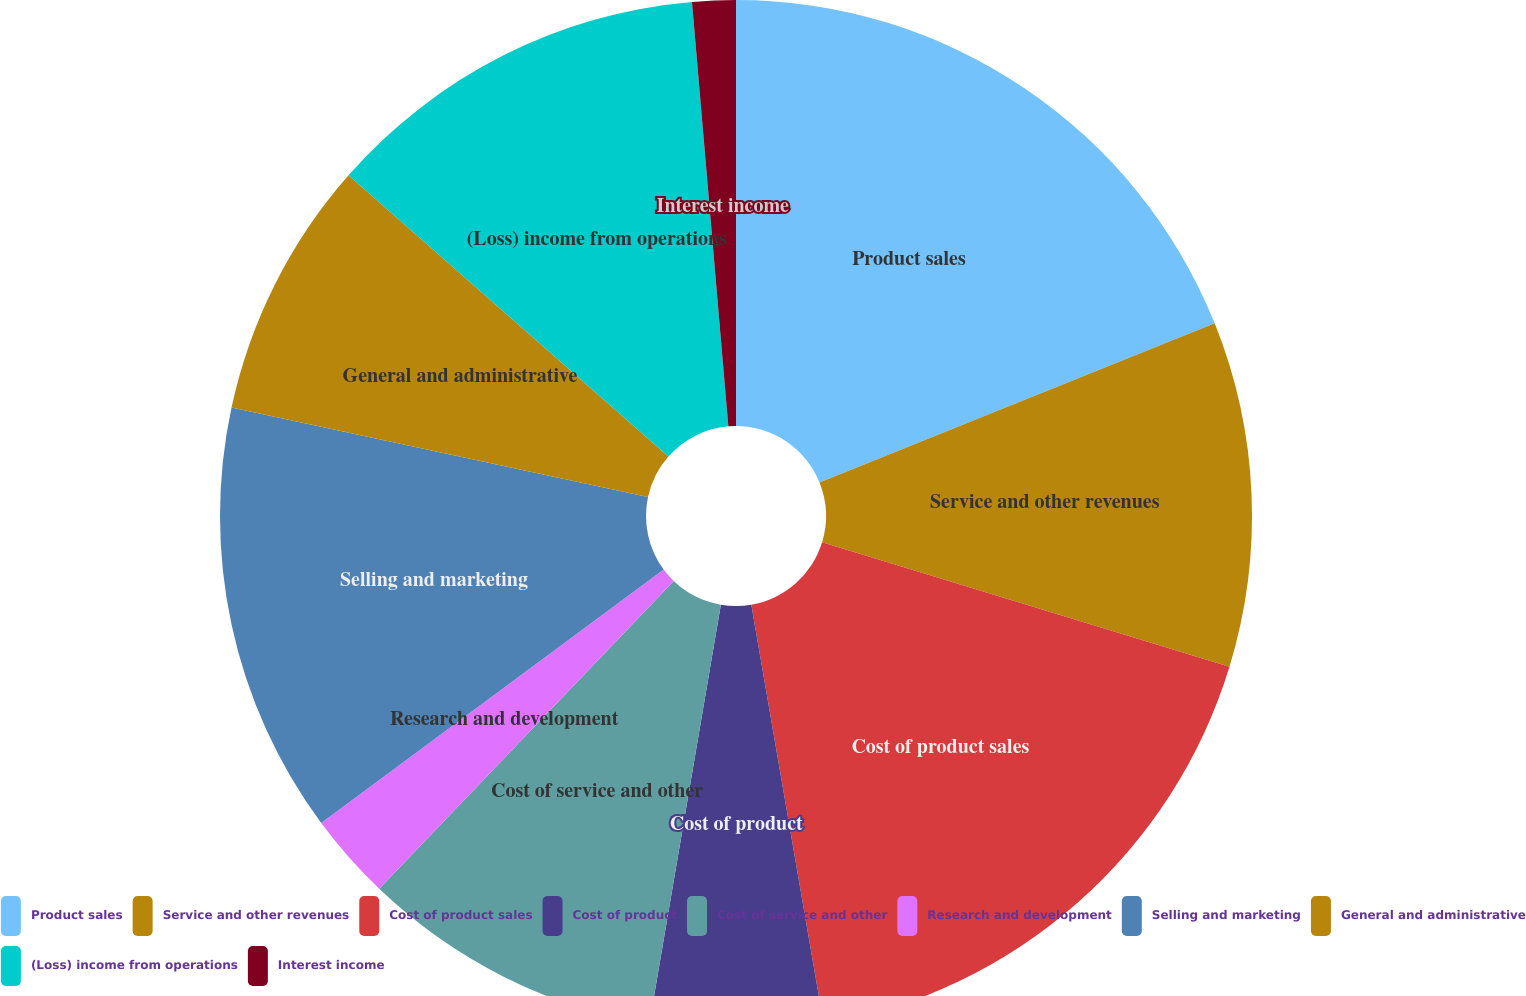Convert chart. <chart><loc_0><loc_0><loc_500><loc_500><pie_chart><fcel>Product sales<fcel>Service and other revenues<fcel>Cost of product sales<fcel>Cost of product<fcel>Cost of service and other<fcel>Research and development<fcel>Selling and marketing<fcel>General and administrative<fcel>(Loss) income from operations<fcel>Interest income<nl><fcel>18.91%<fcel>10.81%<fcel>17.56%<fcel>5.41%<fcel>9.46%<fcel>2.71%<fcel>13.51%<fcel>8.11%<fcel>12.16%<fcel>1.36%<nl></chart> 